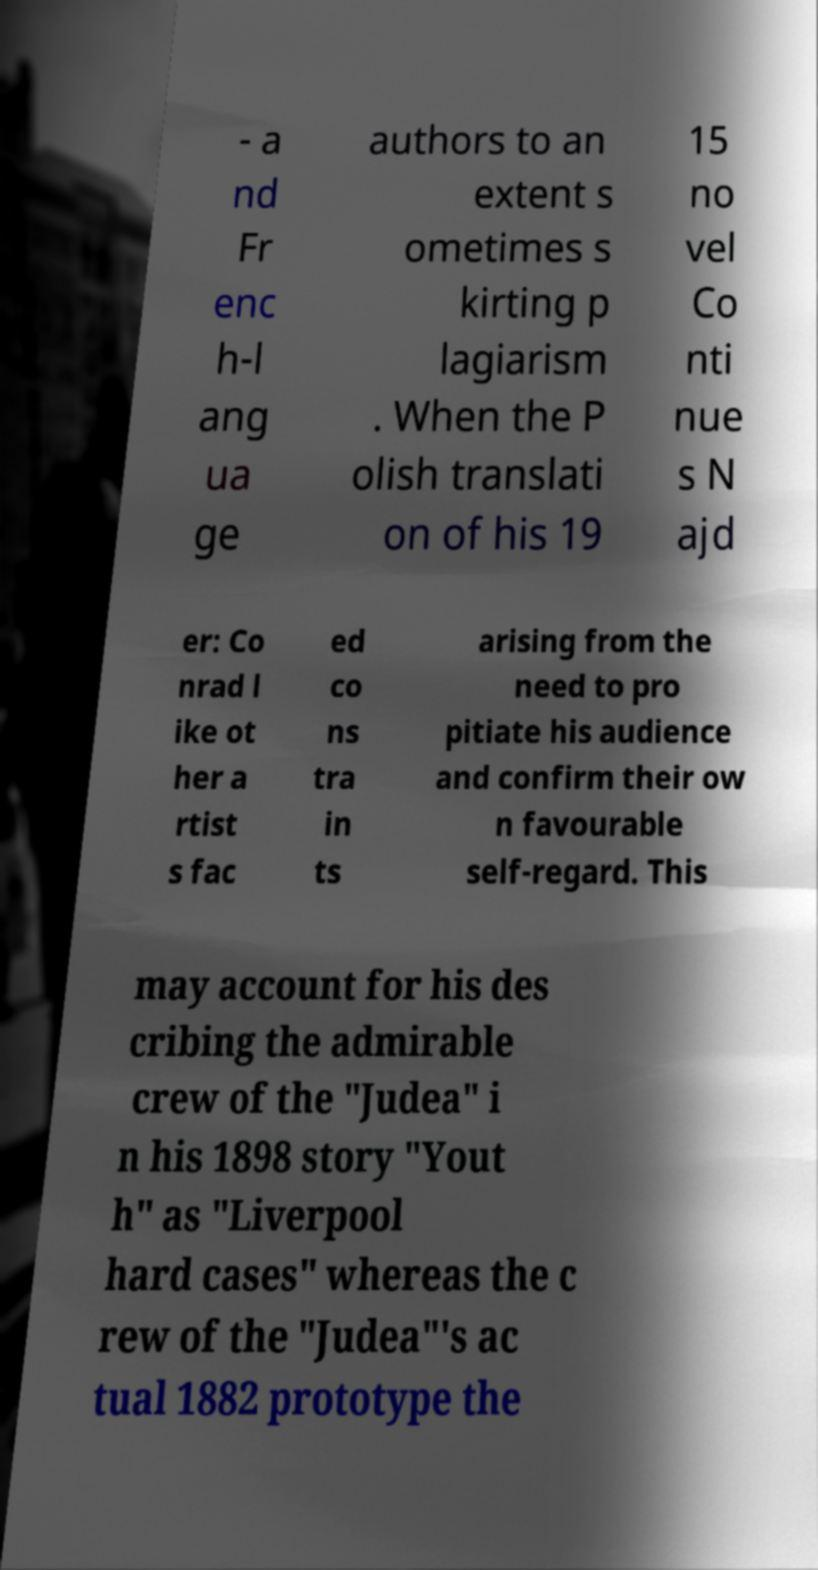I need the written content from this picture converted into text. Can you do that? - a nd Fr enc h-l ang ua ge authors to an extent s ometimes s kirting p lagiarism . When the P olish translati on of his 19 15 no vel Co nti nue s N ajd er: Co nrad l ike ot her a rtist s fac ed co ns tra in ts arising from the need to pro pitiate his audience and confirm their ow n favourable self-regard. This may account for his des cribing the admirable crew of the "Judea" i n his 1898 story "Yout h" as "Liverpool hard cases" whereas the c rew of the "Judea"'s ac tual 1882 prototype the 